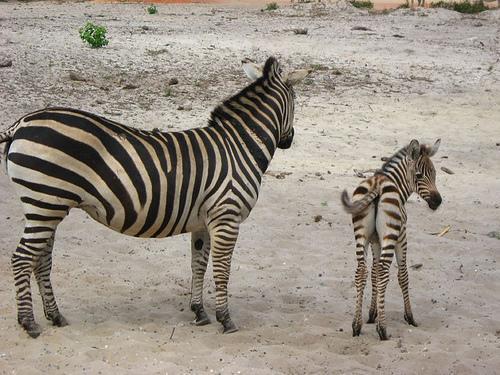How many red crabs are walking in the sand beneath the zebras?
Give a very brief answer. 0. 